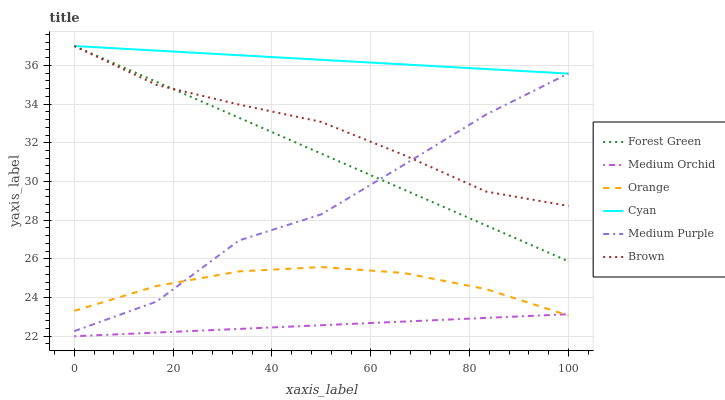Does Medium Orchid have the minimum area under the curve?
Answer yes or no. Yes. Does Cyan have the maximum area under the curve?
Answer yes or no. Yes. Does Medium Purple have the minimum area under the curve?
Answer yes or no. No. Does Medium Purple have the maximum area under the curve?
Answer yes or no. No. Is Cyan the smoothest?
Answer yes or no. Yes. Is Medium Purple the roughest?
Answer yes or no. Yes. Is Medium Orchid the smoothest?
Answer yes or no. No. Is Medium Orchid the roughest?
Answer yes or no. No. Does Medium Purple have the lowest value?
Answer yes or no. No. Does Cyan have the highest value?
Answer yes or no. Yes. Does Medium Purple have the highest value?
Answer yes or no. No. Is Medium Orchid less than Medium Purple?
Answer yes or no. Yes. Is Cyan greater than Orange?
Answer yes or no. Yes. Does Medium Orchid intersect Medium Purple?
Answer yes or no. No. 